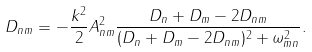Convert formula to latex. <formula><loc_0><loc_0><loc_500><loc_500>D _ { n m } = - \frac { k ^ { 2 } } { 2 } A ^ { 2 } _ { n m } \frac { D _ { n } + D _ { m } - 2 D _ { n m } } { ( D _ { n } + D _ { m } - 2 D _ { n m } ) ^ { 2 } + \omega _ { m n } ^ { 2 } } .</formula> 